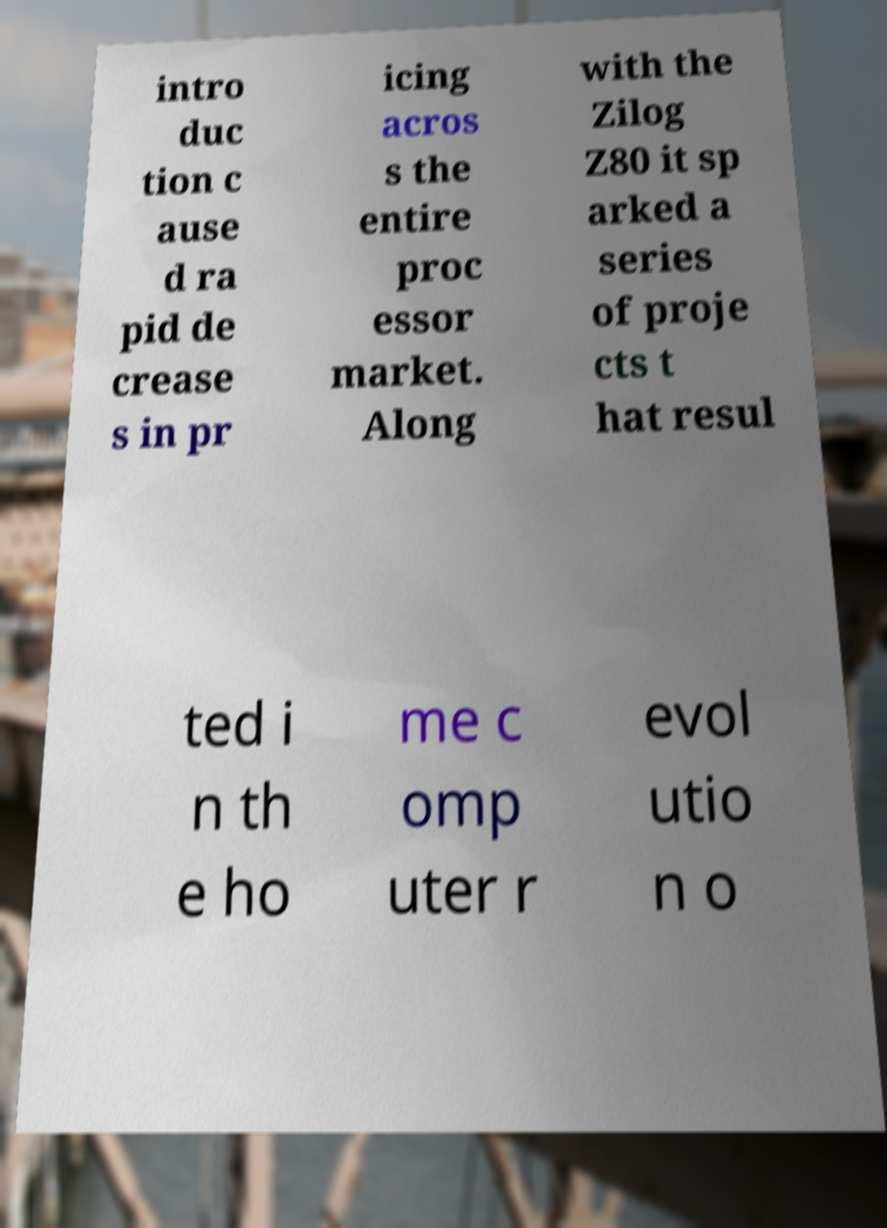Can you read and provide the text displayed in the image?This photo seems to have some interesting text. Can you extract and type it out for me? intro duc tion c ause d ra pid de crease s in pr icing acros s the entire proc essor market. Along with the Zilog Z80 it sp arked a series of proje cts t hat resul ted i n th e ho me c omp uter r evol utio n o 